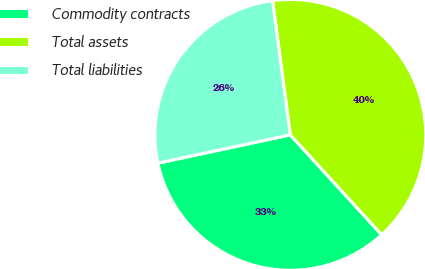Convert chart. <chart><loc_0><loc_0><loc_500><loc_500><pie_chart><fcel>Commodity contracts<fcel>Total assets<fcel>Total liabilities<nl><fcel>33.44%<fcel>40.3%<fcel>26.26%<nl></chart> 